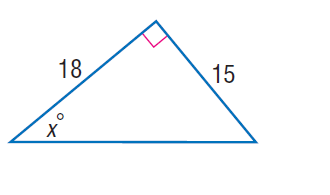Question: Find x.
Choices:
A. 39.8
B. 42.5
C. 67.8
D. 68.9
Answer with the letter. Answer: A 